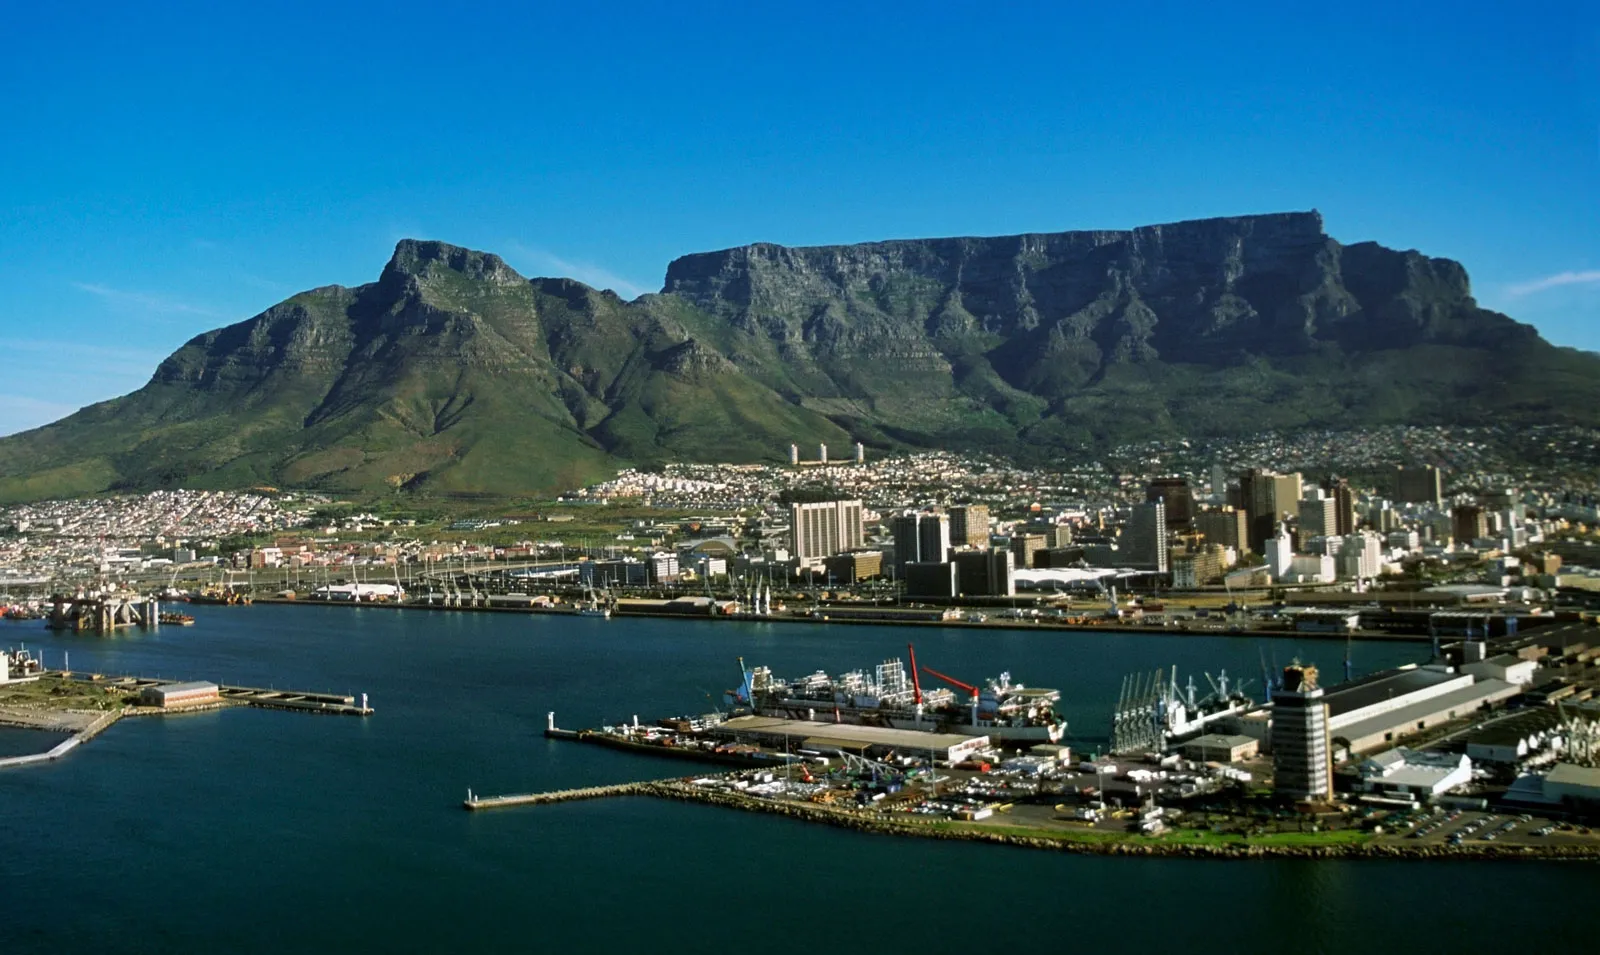What economic activities can be observed in the area shown in the picture? The foreground of this image shows a part of Cape Town's harbor, which reveals a hub of economic activity. As one of the busiest ports in South Africa, it handles significant commercial shipping and is a key point of trade for the country. Both the import and export of goods contribute to its bustling economy. The surrounding areas of the harbor house various industries, including fishing, shipbuilding, and tourism, particularly around the Victoria & Alfred Waterfront, a regenerated historic precinct known for shopping, dining, and entertainment venues, as well as the Two Oceans Aquarium. 